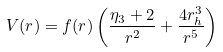<formula> <loc_0><loc_0><loc_500><loc_500>V ( r ) = f ( r ) \left ( \frac { \eta _ { 3 } + 2 } { r ^ { 2 } } + \frac { 4 r _ { h } ^ { 3 } } { r ^ { 5 } } \right )</formula> 